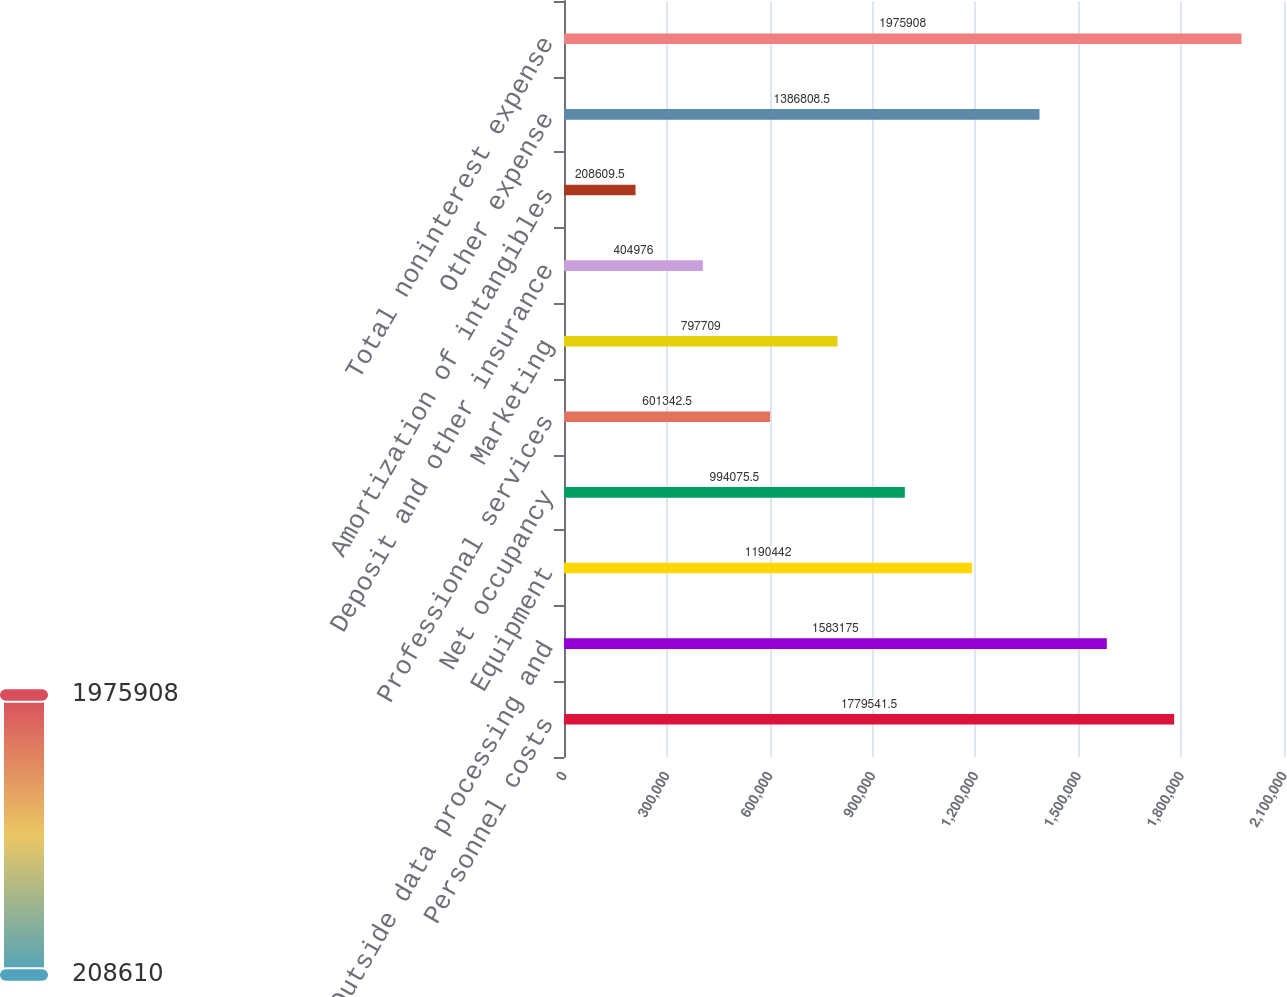Convert chart. <chart><loc_0><loc_0><loc_500><loc_500><bar_chart><fcel>Personnel costs<fcel>Outside data processing and<fcel>Equipment<fcel>Net occupancy<fcel>Professional services<fcel>Marketing<fcel>Deposit and other insurance<fcel>Amortization of intangibles<fcel>Other expense<fcel>Total noninterest expense<nl><fcel>1.77954e+06<fcel>1.58318e+06<fcel>1.19044e+06<fcel>994076<fcel>601342<fcel>797709<fcel>404976<fcel>208610<fcel>1.38681e+06<fcel>1.97591e+06<nl></chart> 